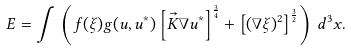<formula> <loc_0><loc_0><loc_500><loc_500>E = \int \, \left ( f ( \xi ) g ( u , u ^ { * } ) \left [ \vec { K } \nabla u ^ { * } \right ] ^ { \frac { 3 } { 4 } } + \left [ ( \nabla \xi ) ^ { 2 } \right ] ^ { \frac { 3 } { 2 } } \right ) \, d ^ { 3 } x .</formula> 